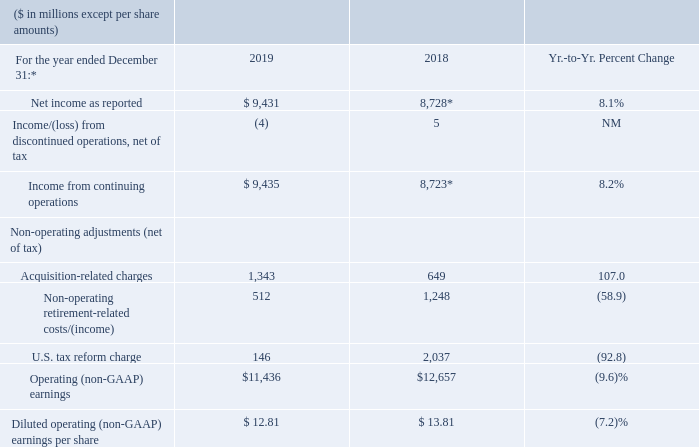The following table provides the company’s operating (non-GAAP) earnings for 2019 and 2018. See page 46 for additional information.
* 2019 results were impacted by Red Hat purchase accounting and acquisition-related activity.
** Includes charges of $2.0 billion in 2018 associated with U.S. tax reform.
In 2018, net income includes what additional charges? Includes charges of $2.0 billion in 2018 associated with u.s. tax reform. In 2019, results were impacted by which activity? 2019 results were impacted by red hat purchase accounting and acquisition-related activity. What was the U.S. tax reform charge in 2019?
Answer scale should be: million. 146. What was the increase / (decrease) in Net income from 2018 to 2019?
Answer scale should be: million. 9,431 - 8,728
Answer: 703. What was the increase / (decrease) in Income from continuing operations from 2018 to 2019?
Answer scale should be: million. 9,435 - 8,723
Answer: 712. What was the increase / (decrease) in Operating (non-GAAP) earnings from continuing operations from 2018 to 2019?
Answer scale should be: million. 11,436 - 12,657
Answer: -1221. 